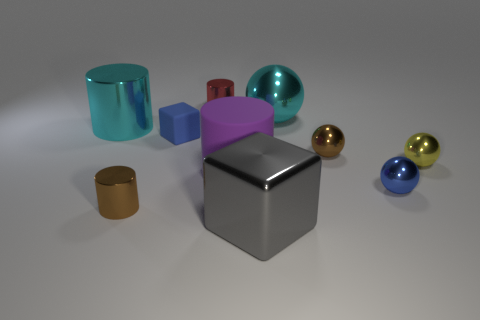Subtract all tiny yellow metallic balls. How many balls are left? 3 Subtract 1 blocks. How many blocks are left? 1 Subtract all cubes. How many objects are left? 8 Subtract all blue spheres. How many spheres are left? 3 Subtract all cyan balls. How many purple cubes are left? 0 Subtract all large spheres. Subtract all red cylinders. How many objects are left? 8 Add 8 small brown metal cylinders. How many small brown metal cylinders are left? 9 Add 1 tiny gray matte objects. How many tiny gray matte objects exist? 1 Subtract 1 blue blocks. How many objects are left? 9 Subtract all cyan cubes. Subtract all purple cylinders. How many cubes are left? 2 